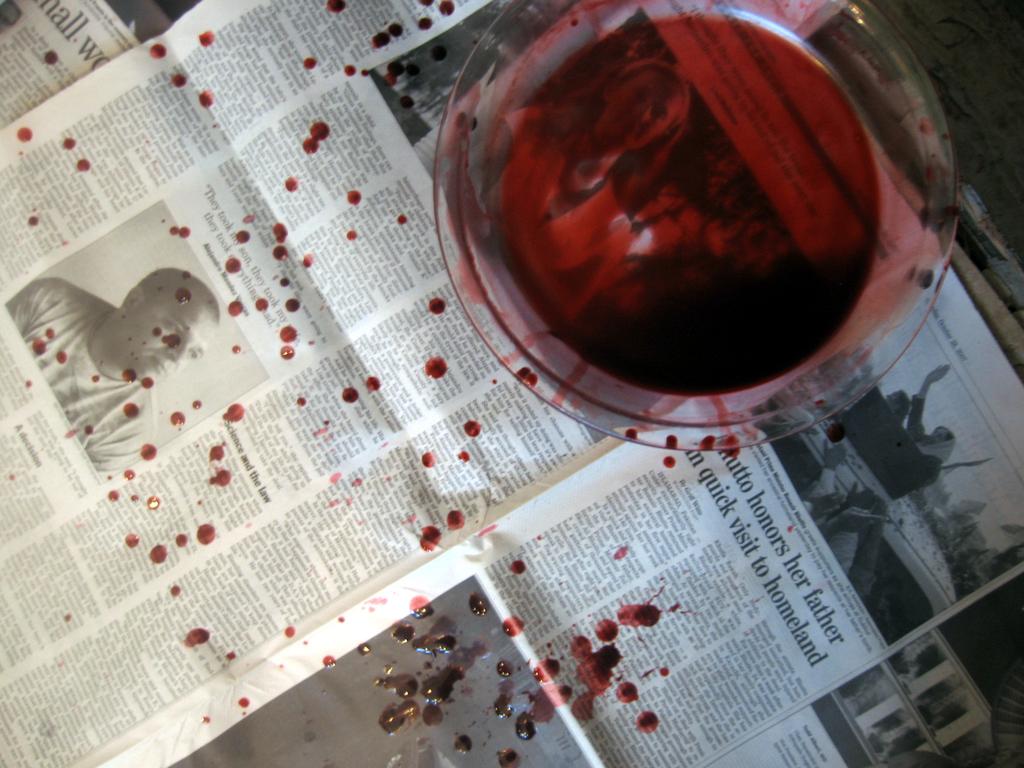In one of these newspaper articles, how did someone honor their father?
Ensure brevity in your answer.  Quick visit to homeland. Who is the person honoring her father?
Provide a succinct answer. Hutto. 